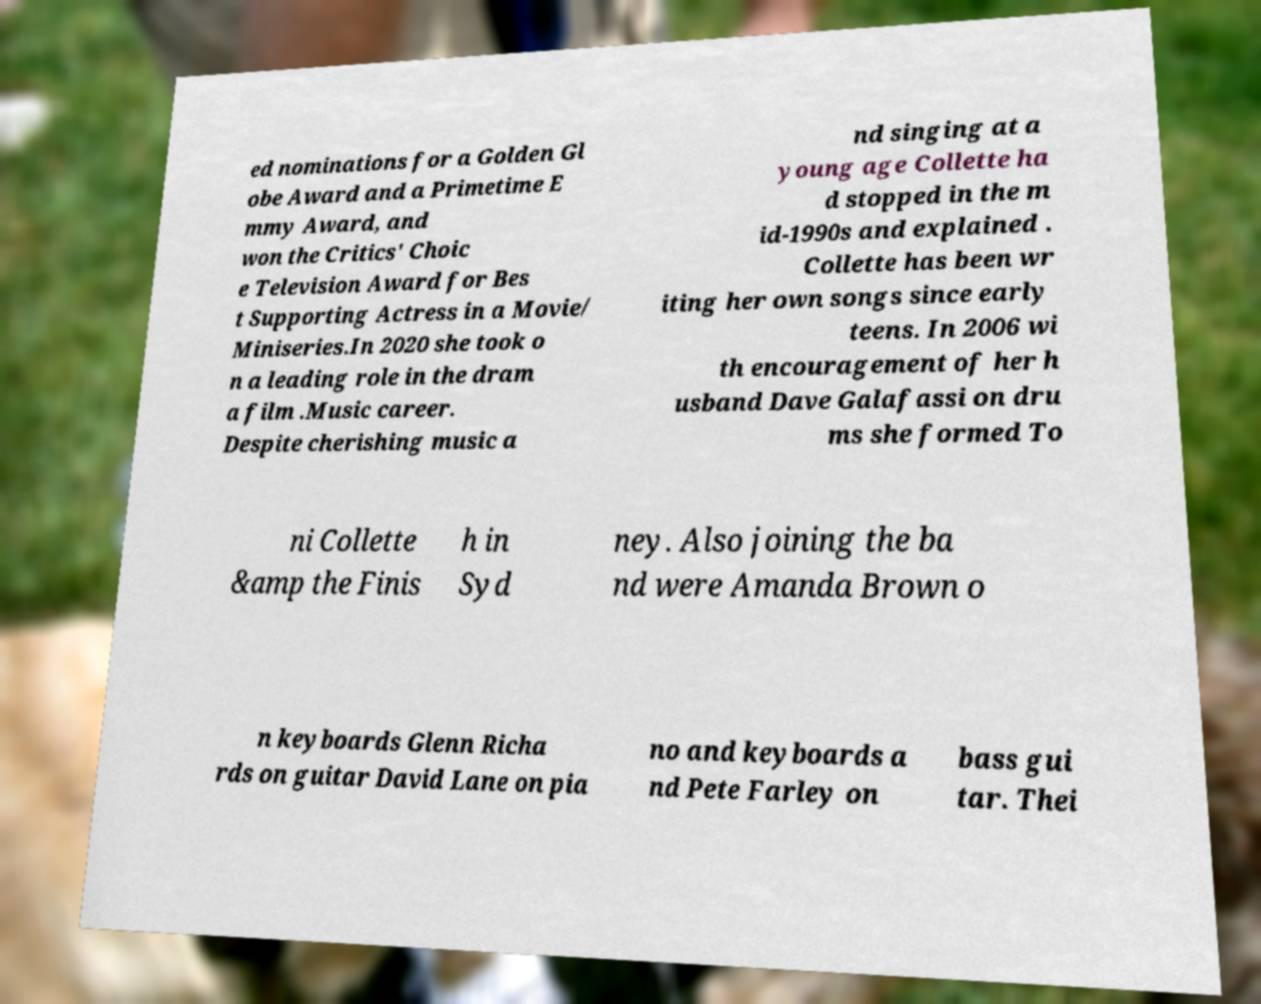Please read and relay the text visible in this image. What does it say? ed nominations for a Golden Gl obe Award and a Primetime E mmy Award, and won the Critics' Choic e Television Award for Bes t Supporting Actress in a Movie/ Miniseries.In 2020 she took o n a leading role in the dram a film .Music career. Despite cherishing music a nd singing at a young age Collette ha d stopped in the m id-1990s and explained . Collette has been wr iting her own songs since early teens. In 2006 wi th encouragement of her h usband Dave Galafassi on dru ms she formed To ni Collette &amp the Finis h in Syd ney. Also joining the ba nd were Amanda Brown o n keyboards Glenn Richa rds on guitar David Lane on pia no and keyboards a nd Pete Farley on bass gui tar. Thei 